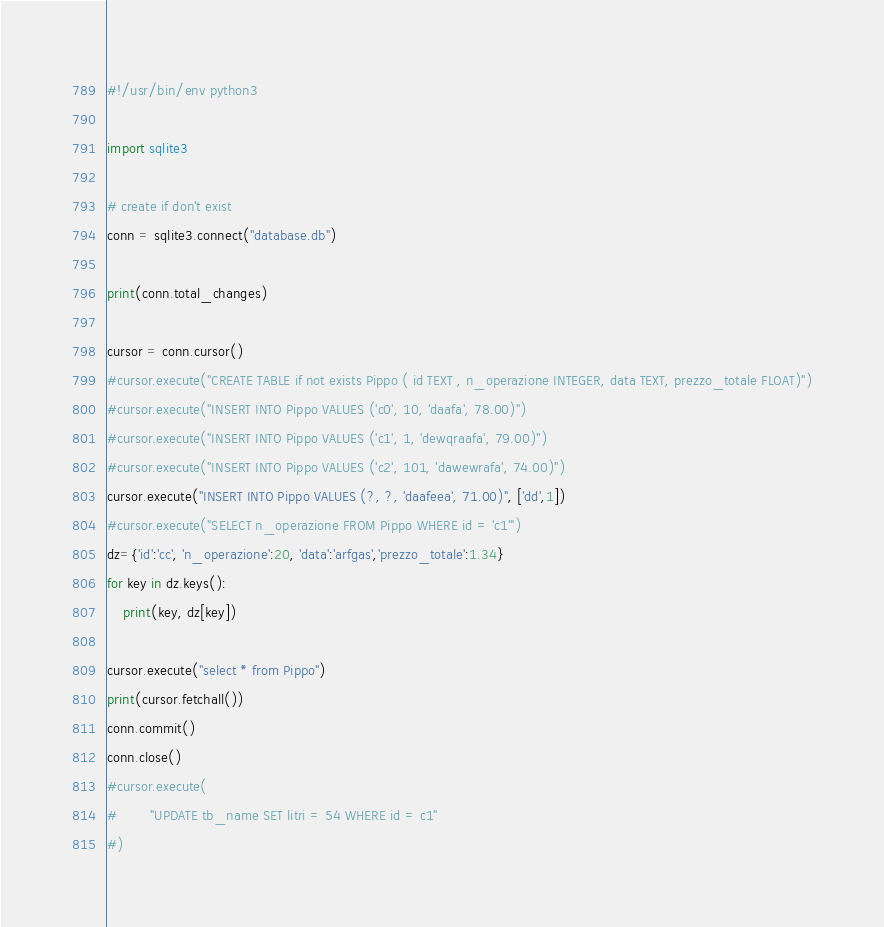<code> <loc_0><loc_0><loc_500><loc_500><_Python_>#!/usr/bin/env python3

import sqlite3

# create if don't exist
conn = sqlite3.connect("database.db")

print(conn.total_changes)

cursor = conn.cursor()
#cursor.execute("CREATE TABLE if not exists Pippo ( id TEXT , n_operazione INTEGER, data TEXT, prezzo_totale FLOAT)")
#cursor.execute("INSERT INTO Pippo VALUES ('c0', 10, 'daafa', 78.00)")
#cursor.execute("INSERT INTO Pippo VALUES ('c1', 1, 'dewqraafa', 79.00)")
#cursor.execute("INSERT INTO Pippo VALUES ('c2', 101, 'dawewrafa', 74.00)")
cursor.execute("INSERT INTO Pippo VALUES (?, ?, 'daafeea', 71.00)", ['dd',1])
#cursor.execute("SELECT n_operazione FROM Pippo WHERE id = 'c1'")
dz={'id':'cc', 'n_operazione':20, 'data':'arfgas','prezzo_totale':1.34}
for key in dz.keys():
    print(key, dz[key])

cursor.execute("select * from Pippo")
print(cursor.fetchall())
conn.commit()
conn.close()
#cursor.execute(
#        "UPDATE tb_name SET litri = 54 WHERE id = c1"        
#)

</code> 